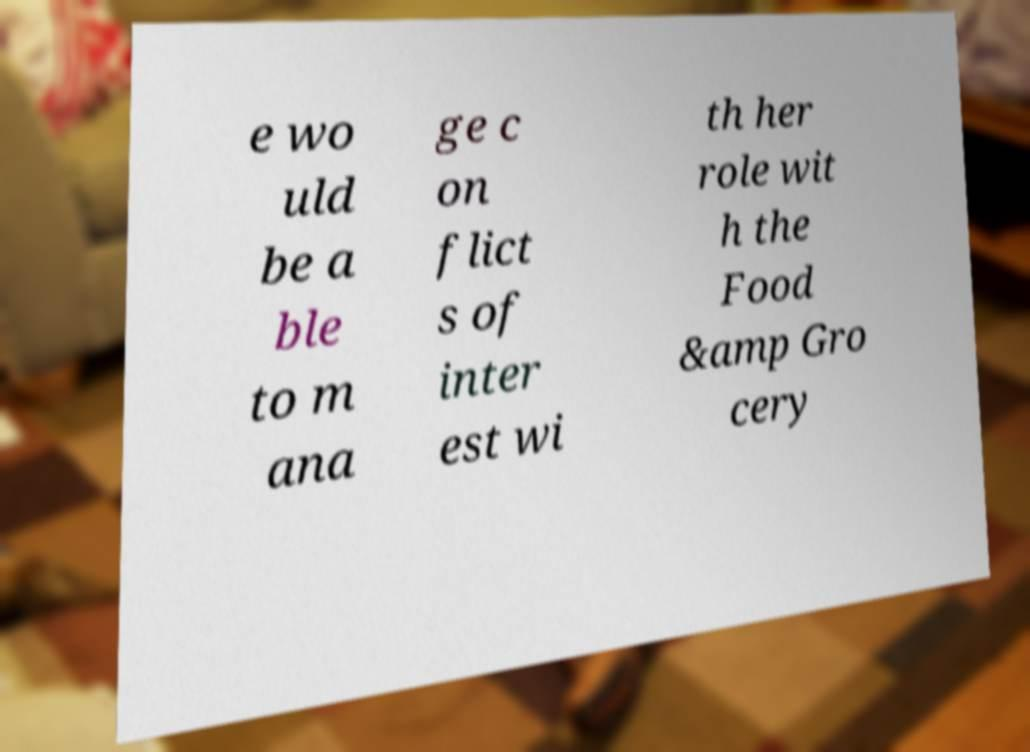Please read and relay the text visible in this image. What does it say? e wo uld be a ble to m ana ge c on flict s of inter est wi th her role wit h the Food &amp Gro cery 